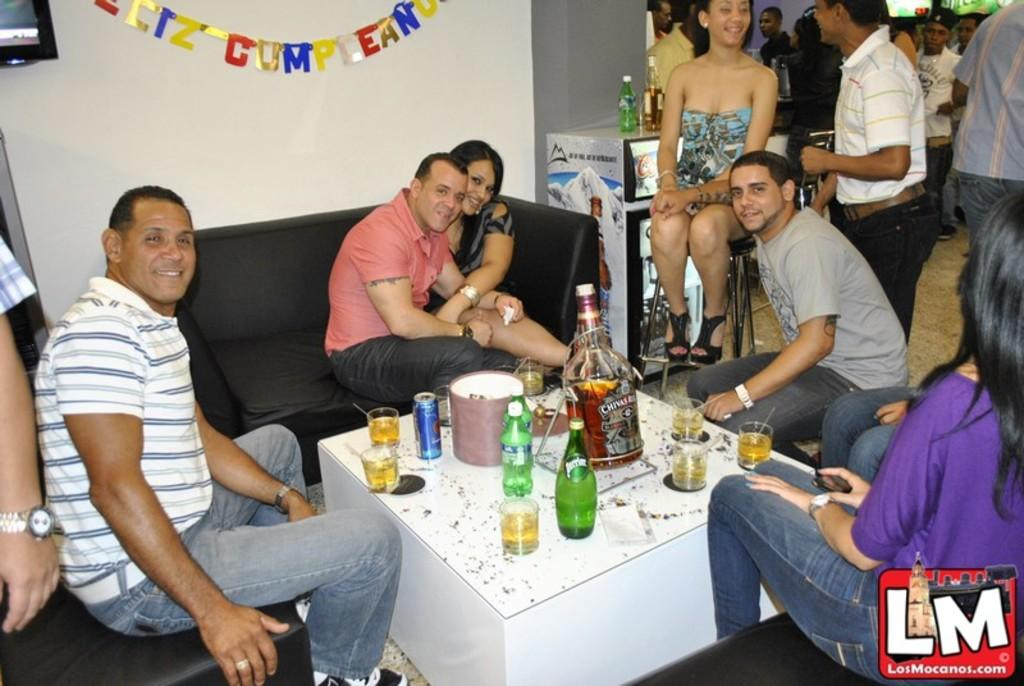What are the people in the image doing? There is a group of people sitting in the image. What objects are on the table in the image? There are bottles and glasses on a table in the image. What can be seen in the background of the image? There is a wall visible in the background of the image. What type of peace symbol can be seen on the wall in the image? There is no peace symbol visible on the wall in the image. What route are the people in the image taking? There is no indication of a route being taken by the people in the image. 